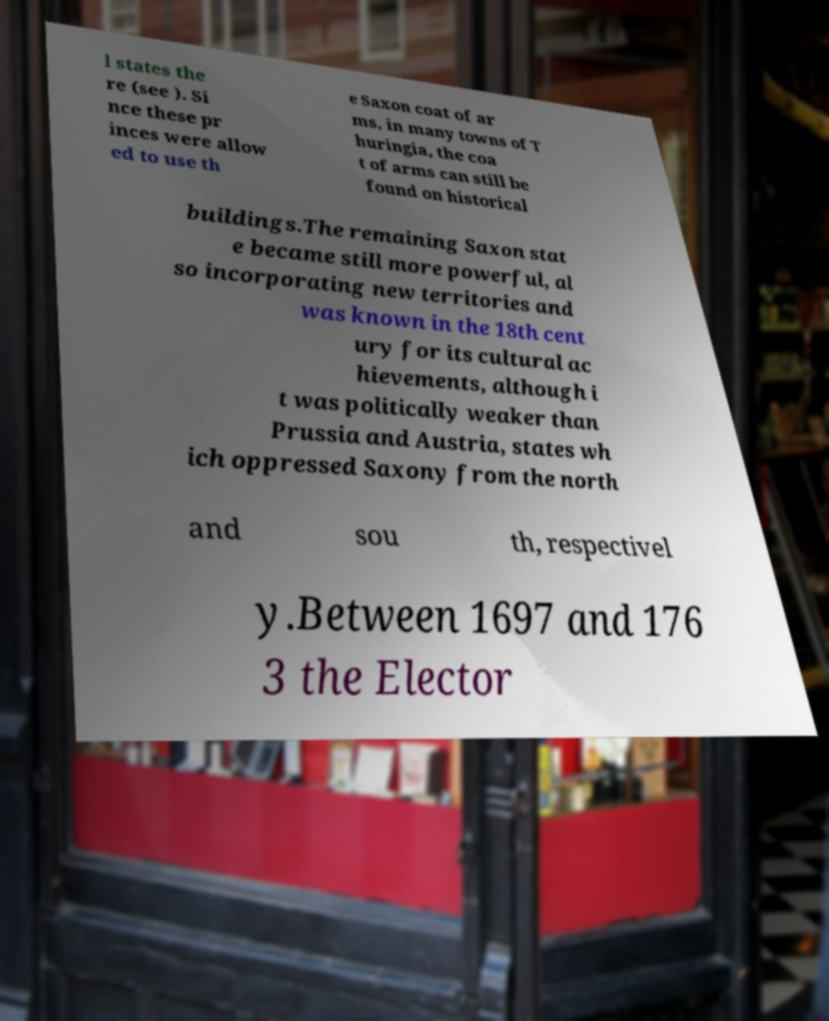Can you accurately transcribe the text from the provided image for me? l states the re (see ). Si nce these pr inces were allow ed to use th e Saxon coat of ar ms, in many towns of T huringia, the coa t of arms can still be found on historical buildings.The remaining Saxon stat e became still more powerful, al so incorporating new territories and was known in the 18th cent ury for its cultural ac hievements, although i t was politically weaker than Prussia and Austria, states wh ich oppressed Saxony from the north and sou th, respectivel y.Between 1697 and 176 3 the Elector 